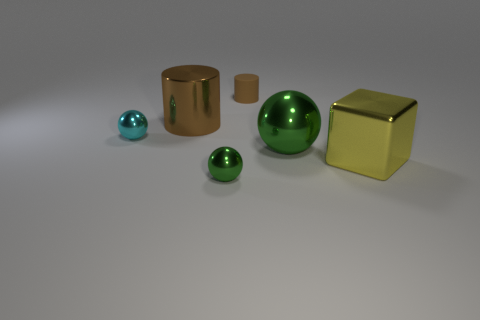Add 2 cyan metallic balls. How many objects exist? 8 Subtract all green spheres. How many spheres are left? 1 Add 2 gray balls. How many gray balls exist? 2 Subtract all green balls. How many balls are left? 1 Subtract 1 yellow cubes. How many objects are left? 5 Subtract all blocks. How many objects are left? 5 Subtract 2 spheres. How many spheres are left? 1 Subtract all green cylinders. Subtract all cyan spheres. How many cylinders are left? 2 Subtract all brown spheres. How many yellow cylinders are left? 0 Subtract all purple metallic cylinders. Subtract all tiny cylinders. How many objects are left? 5 